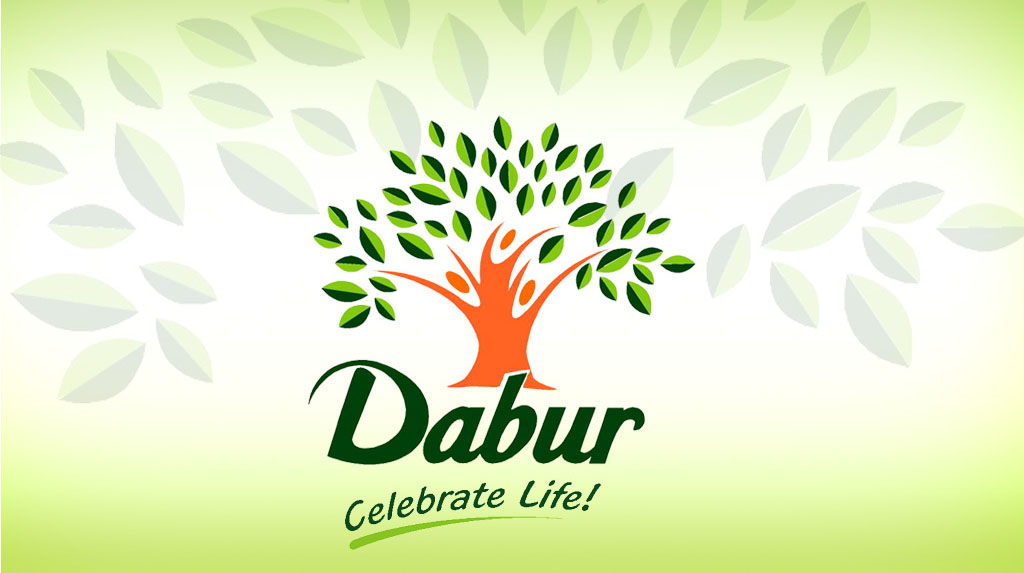What specific elements of the image suggest the company values eco-friendliness? The rich green leaves, a symbol of growth and vitality, coupled with the human figure transitioning seamlessly into the tree, reflect a dedication to melding human life with the natural world. This implies that the company focuses on products that harmonize with the environment, steering away from harmful practices and promoting sustainability. 